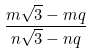<formula> <loc_0><loc_0><loc_500><loc_500>\frac { m { \sqrt { 3 } } - m q } { n { \sqrt { 3 } } - n q }</formula> 